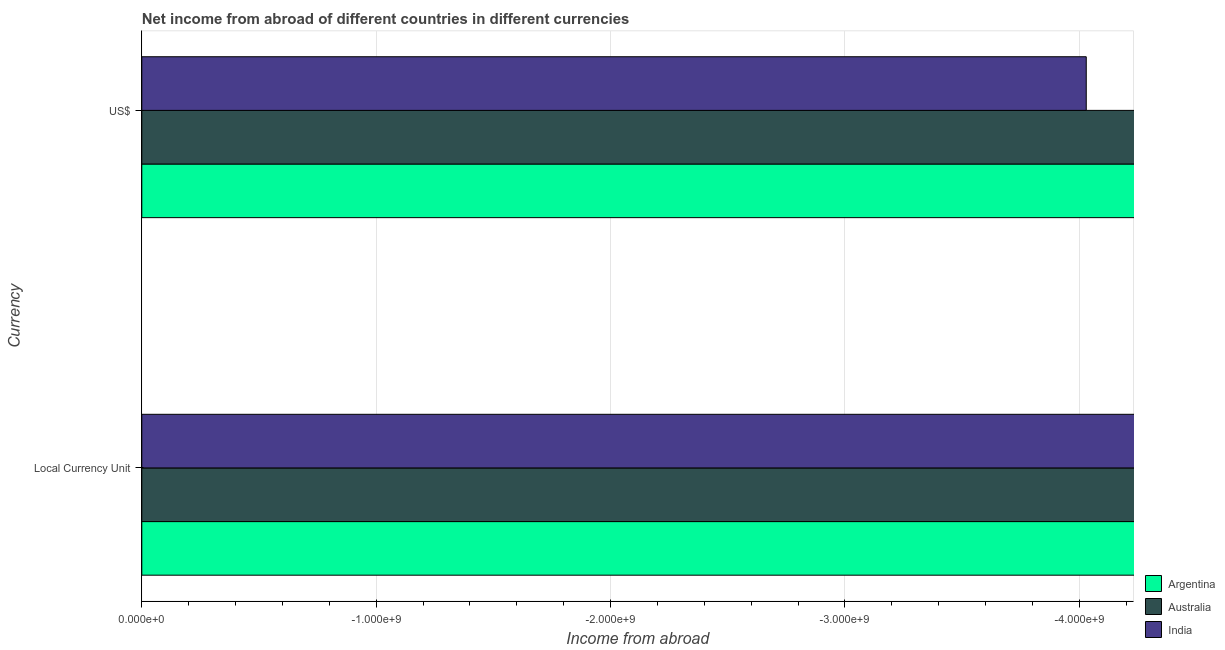Are the number of bars per tick equal to the number of legend labels?
Make the answer very short. No. Are the number of bars on each tick of the Y-axis equal?
Make the answer very short. Yes. How many bars are there on the 1st tick from the top?
Your answer should be compact. 0. What is the label of the 2nd group of bars from the top?
Your answer should be very brief. Local Currency Unit. What is the total income from abroad in constant 2005 us$ in the graph?
Give a very brief answer. 0. What is the difference between the income from abroad in constant 2005 us$ in India and the income from abroad in us$ in Argentina?
Provide a succinct answer. 0. In how many countries, is the income from abroad in us$ greater than -3000000000 units?
Make the answer very short. 0. In how many countries, is the income from abroad in us$ greater than the average income from abroad in us$ taken over all countries?
Keep it short and to the point. 0. How many bars are there?
Offer a very short reply. 0. Are the values on the major ticks of X-axis written in scientific E-notation?
Offer a terse response. Yes. Does the graph contain grids?
Make the answer very short. Yes. How many legend labels are there?
Give a very brief answer. 3. How are the legend labels stacked?
Ensure brevity in your answer.  Vertical. What is the title of the graph?
Your response must be concise. Net income from abroad of different countries in different currencies. What is the label or title of the X-axis?
Offer a very short reply. Income from abroad. What is the label or title of the Y-axis?
Your response must be concise. Currency. What is the Income from abroad of Australia in Local Currency Unit?
Your answer should be very brief. 0. What is the total Income from abroad of India in the graph?
Ensure brevity in your answer.  0. What is the average Income from abroad in Australia per Currency?
Keep it short and to the point. 0. What is the average Income from abroad of India per Currency?
Give a very brief answer. 0. 